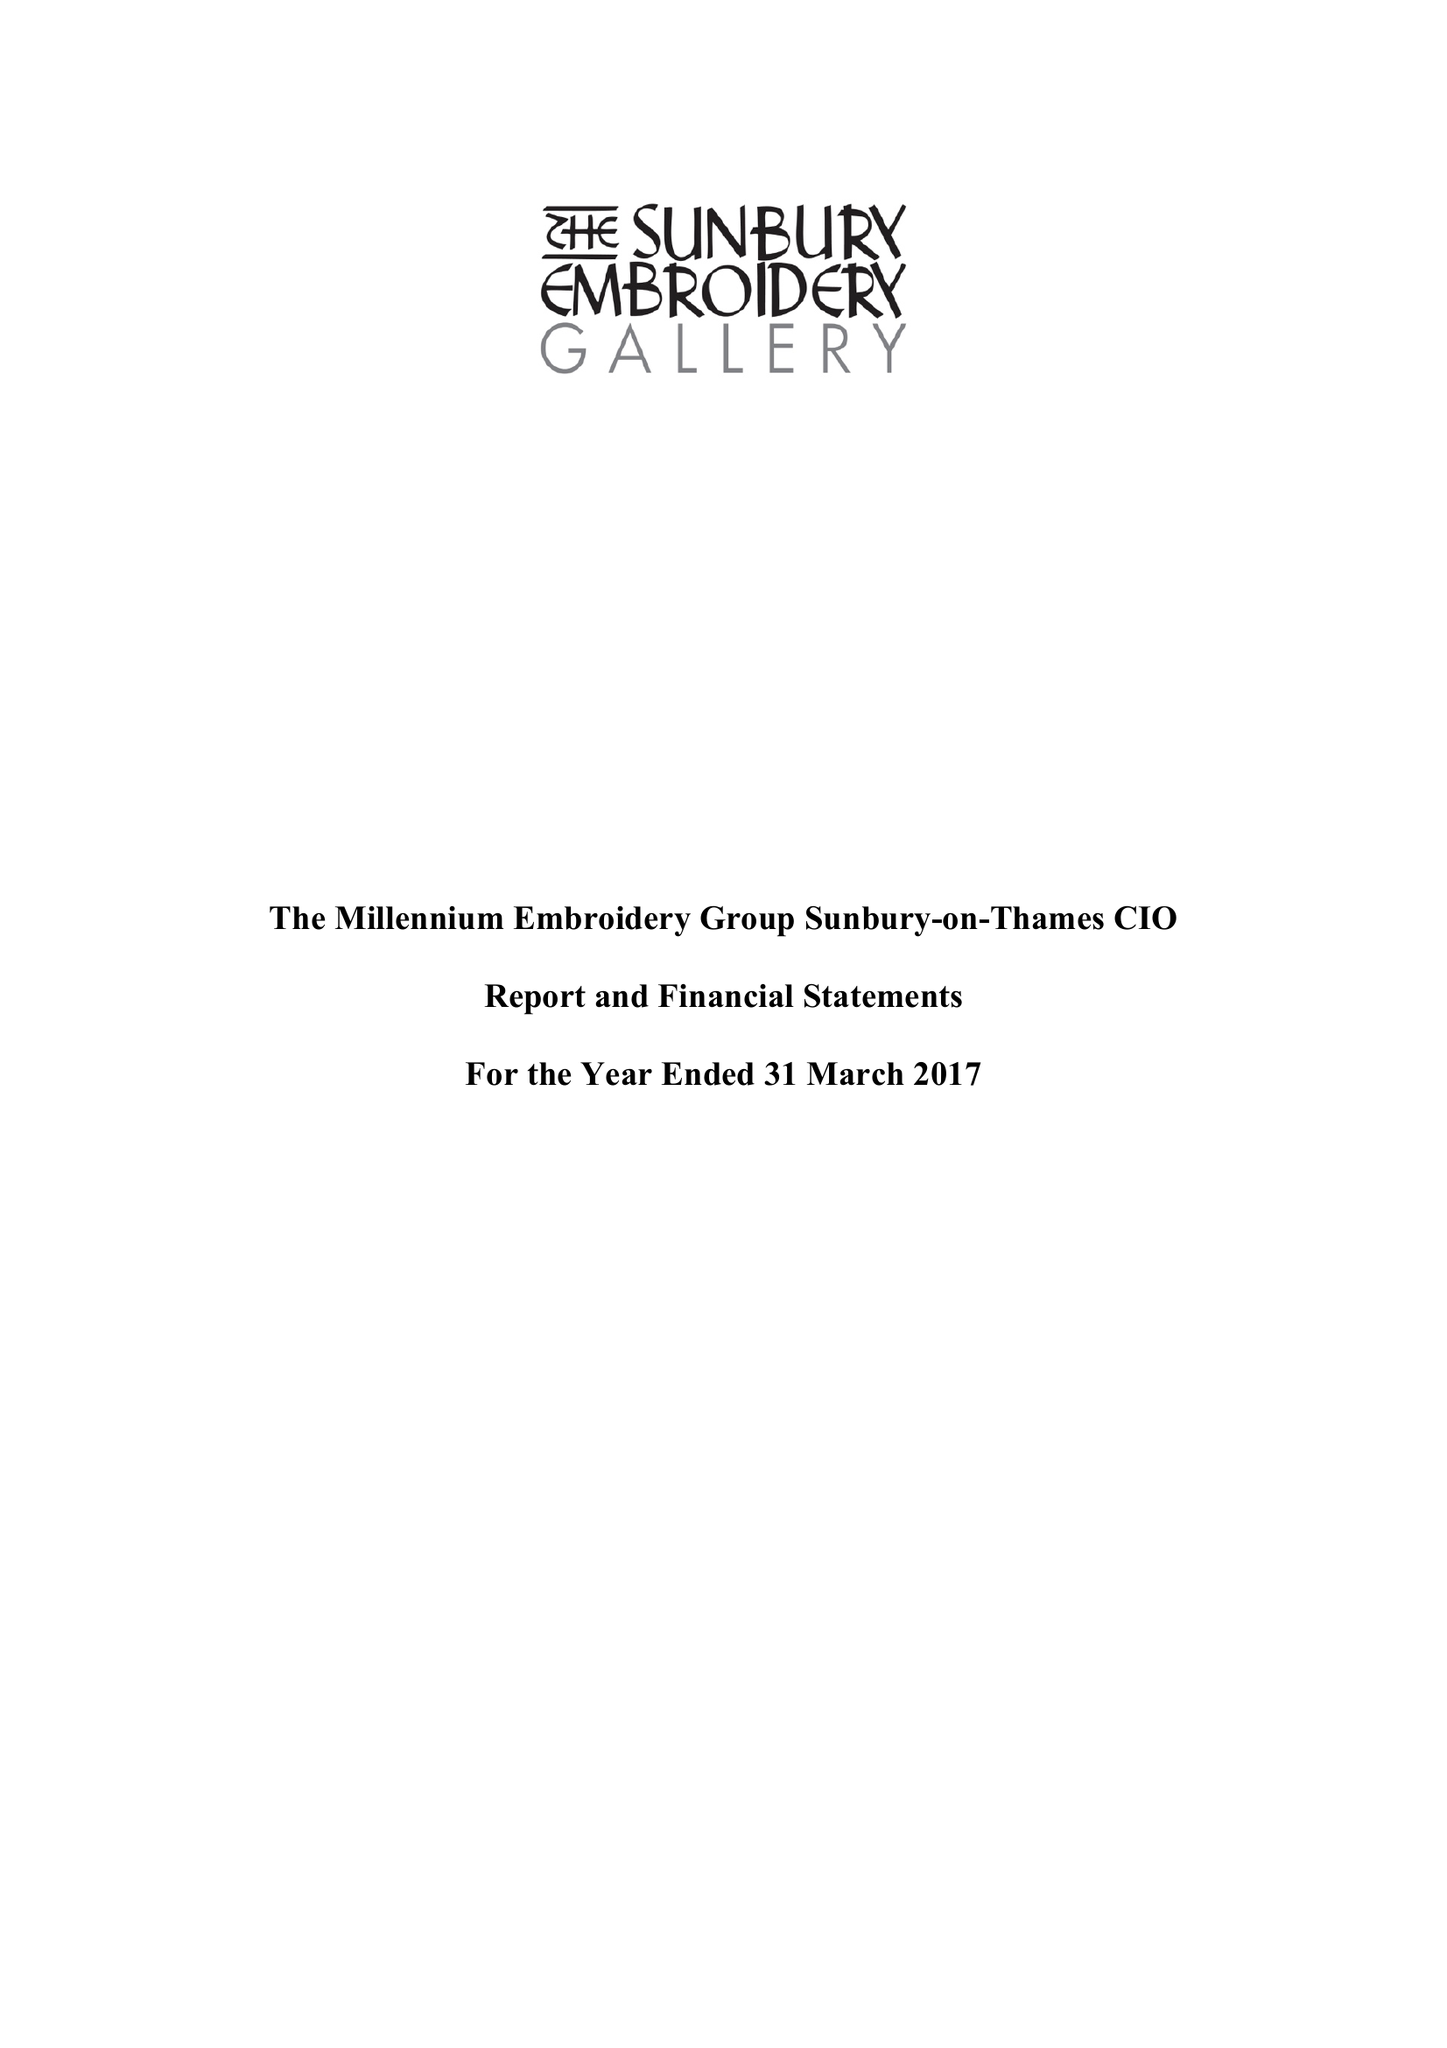What is the value for the address__postcode?
Answer the question using a single word or phrase. TW16 6AB 